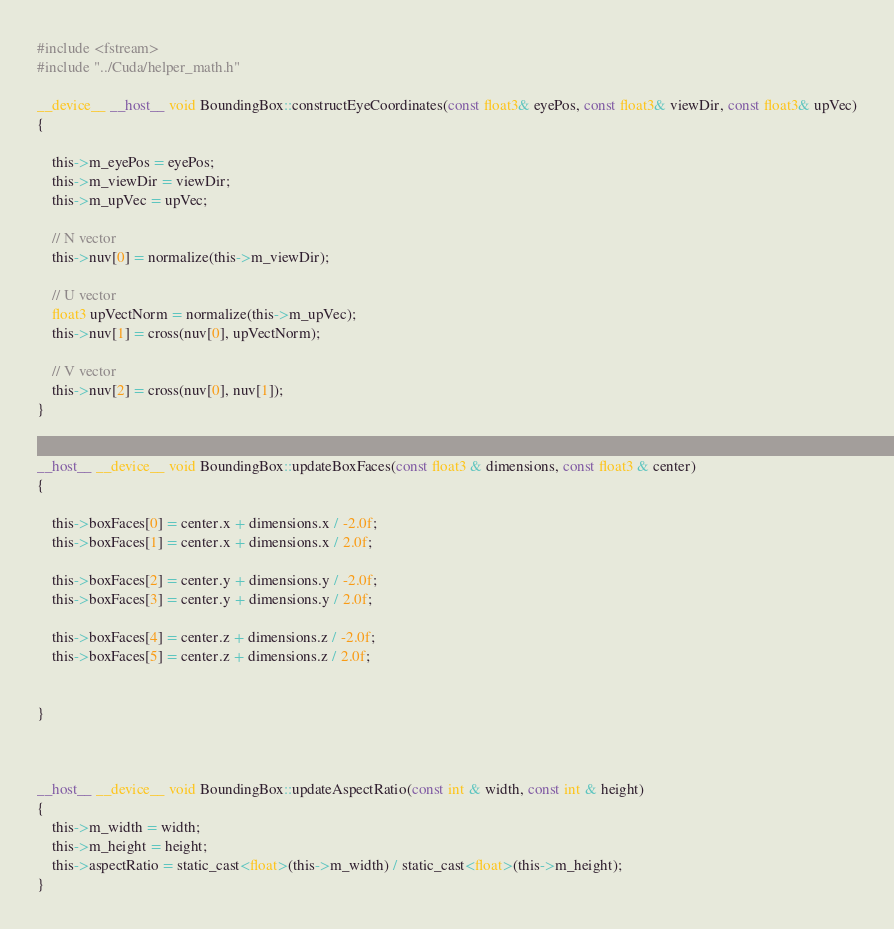Convert code to text. <code><loc_0><loc_0><loc_500><loc_500><_Cuda_>#include <fstream>
#include "../Cuda/helper_math.h"

__device__ __host__ void BoundingBox::constructEyeCoordinates(const float3& eyePos, const float3& viewDir, const float3& upVec)
{

	this->m_eyePos = eyePos;
	this->m_viewDir = viewDir;
	this->m_upVec = upVec;

	// N vector
	this->nuv[0] = normalize(this->m_viewDir);

	// U vector
	float3 upVectNorm = normalize(this->m_upVec);
	this->nuv[1] = cross(nuv[0], upVectNorm);

	// V vector
	this->nuv[2] = cross(nuv[0], nuv[1]);
}


__host__ __device__ void BoundingBox::updateBoxFaces(const float3 & dimensions, const float3 & center)
{

	this->boxFaces[0] = center.x + dimensions.x / -2.0f;
	this->boxFaces[1] = center.x + dimensions.x / 2.0f;

	this->boxFaces[2] = center.y + dimensions.y / -2.0f;
	this->boxFaces[3] = center.y + dimensions.y / 2.0f;

	this->boxFaces[4] = center.z + dimensions.z / -2.0f;
	this->boxFaces[5] = center.z + dimensions.z / 2.0f;


}



__host__ __device__ void BoundingBox::updateAspectRatio(const int & width, const int & height)
{
	this->m_width = width;
	this->m_height = height;
	this->aspectRatio = static_cast<float>(this->m_width) / static_cast<float>(this->m_height);
}</code> 